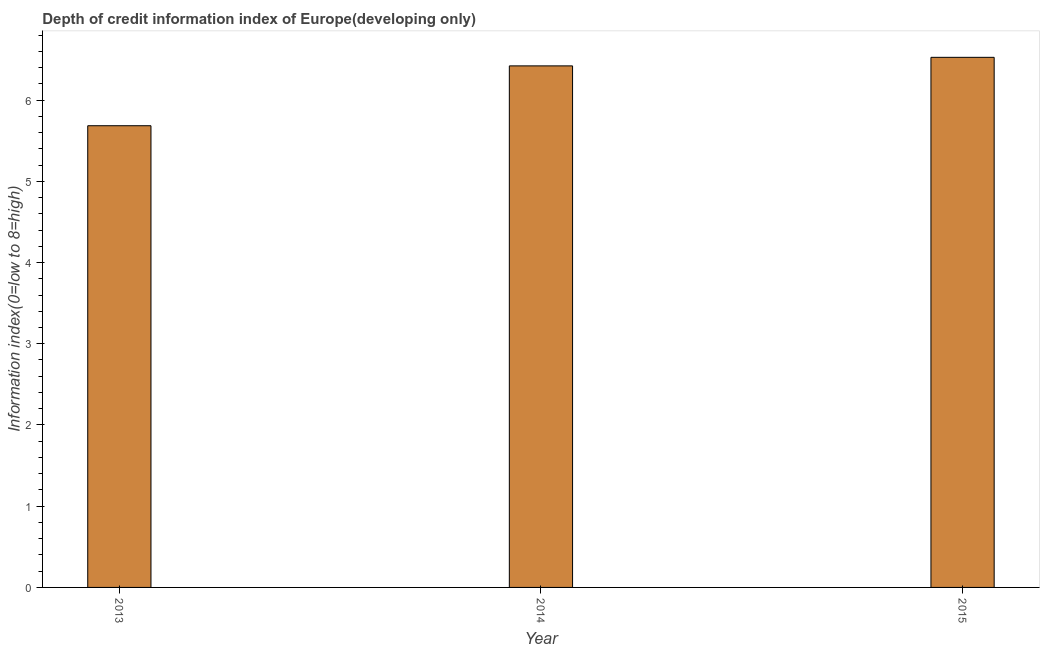Does the graph contain grids?
Ensure brevity in your answer.  No. What is the title of the graph?
Make the answer very short. Depth of credit information index of Europe(developing only). What is the label or title of the Y-axis?
Provide a short and direct response. Information index(0=low to 8=high). What is the depth of credit information index in 2014?
Provide a succinct answer. 6.42. Across all years, what is the maximum depth of credit information index?
Your answer should be very brief. 6.53. Across all years, what is the minimum depth of credit information index?
Offer a terse response. 5.68. In which year was the depth of credit information index maximum?
Your answer should be very brief. 2015. In which year was the depth of credit information index minimum?
Offer a very short reply. 2013. What is the sum of the depth of credit information index?
Your answer should be very brief. 18.63. What is the difference between the depth of credit information index in 2013 and 2014?
Ensure brevity in your answer.  -0.74. What is the average depth of credit information index per year?
Keep it short and to the point. 6.21. What is the median depth of credit information index?
Give a very brief answer. 6.42. In how many years, is the depth of credit information index greater than 2 ?
Your answer should be very brief. 3. What is the ratio of the depth of credit information index in 2013 to that in 2014?
Offer a terse response. 0.89. Is the difference between the depth of credit information index in 2013 and 2015 greater than the difference between any two years?
Your response must be concise. Yes. What is the difference between the highest and the second highest depth of credit information index?
Ensure brevity in your answer.  0.1. What is the difference between the highest and the lowest depth of credit information index?
Your answer should be very brief. 0.84. In how many years, is the depth of credit information index greater than the average depth of credit information index taken over all years?
Ensure brevity in your answer.  2. How many bars are there?
Keep it short and to the point. 3. Are all the bars in the graph horizontal?
Provide a succinct answer. No. How many years are there in the graph?
Offer a terse response. 3. Are the values on the major ticks of Y-axis written in scientific E-notation?
Ensure brevity in your answer.  No. What is the Information index(0=low to 8=high) of 2013?
Make the answer very short. 5.68. What is the Information index(0=low to 8=high) of 2014?
Your answer should be compact. 6.42. What is the Information index(0=low to 8=high) in 2015?
Your answer should be very brief. 6.53. What is the difference between the Information index(0=low to 8=high) in 2013 and 2014?
Provide a succinct answer. -0.74. What is the difference between the Information index(0=low to 8=high) in 2013 and 2015?
Provide a short and direct response. -0.84. What is the difference between the Information index(0=low to 8=high) in 2014 and 2015?
Offer a terse response. -0.11. What is the ratio of the Information index(0=low to 8=high) in 2013 to that in 2014?
Offer a terse response. 0.89. What is the ratio of the Information index(0=low to 8=high) in 2013 to that in 2015?
Provide a succinct answer. 0.87. 